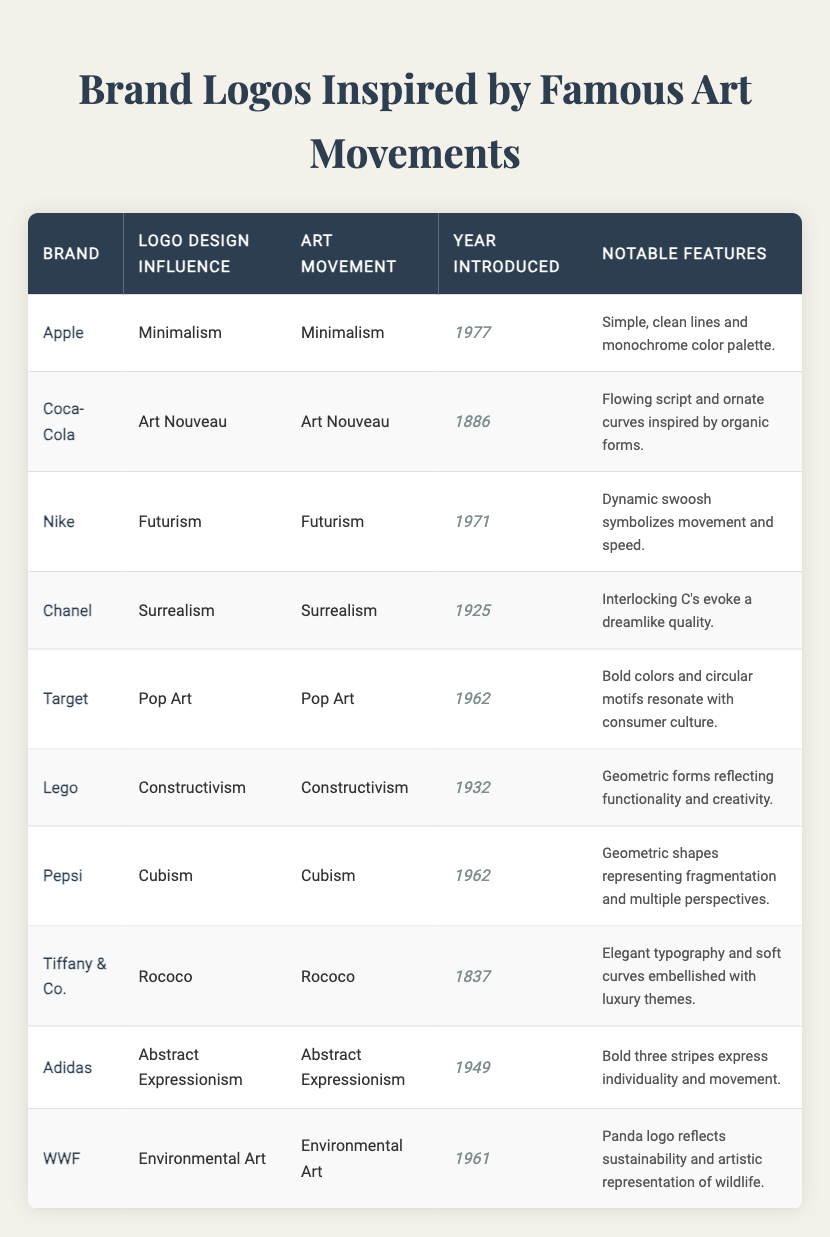What is the brand inspired by Minimalism? Looking at the table, the brand with a logo design influence from Minimalism is Apple, which introduced its logo in 1977.
Answer: Apple Which brand's logo features geometric shapes representing Cubism? The table indicates that Pepsi's logo embodies Cubism and was introduced in 1962.
Answer: Pepsi How many brands introduced their logos in the 1960s? From the table, the brands that introduced their logos in the 1960s are Target, Pepsi, and WWF, totaling three brands.
Answer: 3 What notable feature does the Coca-Cola logo have? According to the table, Coca-Cola's notable feature is its flowing script and ornate curves inspired by organic forms.
Answer: Flowing script and ornate curves Is the Apple logo influenced by Abstract Expressionism? Referring to the table, the Apple logo's design influence is Minimalism, not Abstract Expressionism. Therefore, the answer is no.
Answer: No Which art movement has the earliest introduction date in the table? By examining the introduction years listed in the table, Tiffany & Co. has the earliest introduction date in 1837.
Answer: Rococo What is the notable feature shared by the logos of Chanel and Adidas? Both logos share the theme of individuality and creativity, as Chanel's interlocking C's evoke a dreamlike quality while Adidas's stripes express individuality.
Answer: Individuality and creativity Which logo design influence corresponds to the highest year of introduction? Analyzing the table, the logo with the latest introduction year is Apple's, introduced in 1977, influenced by Minimalism.
Answer: Minimalism Which brand introduced its logo first, Coca-Cola or Tiffany & Co.? By comparing the years in the table, Tiffany & Co. was introduced in 1837, while Coca-Cola was introduced in 1886, showing Tiffany & Co. was first.
Answer: Tiffany & Co How many logos were influenced by movements related to speed or motion? The table lists Nike (Futurism) and Adidas (Abstract Expressionism) as influenced by art movements related to speed or motion, totaling two logos.
Answer: 2 